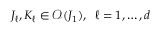<formula> <loc_0><loc_0><loc_500><loc_500>J _ { \ell } , K _ { \ell } \in \mathcal { O } ( J _ { 1 } ) , \, \ell = 1 , \dots , d</formula> 